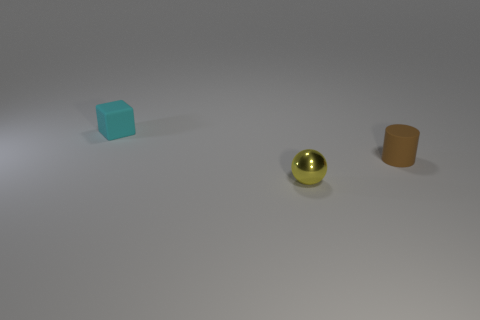There is a small object in front of the tiny matte object right of the small matte thing behind the tiny cylinder; what is its color? The small object in front of the tiny matte blue cube, which is to the right of the small matte orange cylinder, is indeed yellow. It's a shiny, reflective surface distinguishes it from the other objects. 